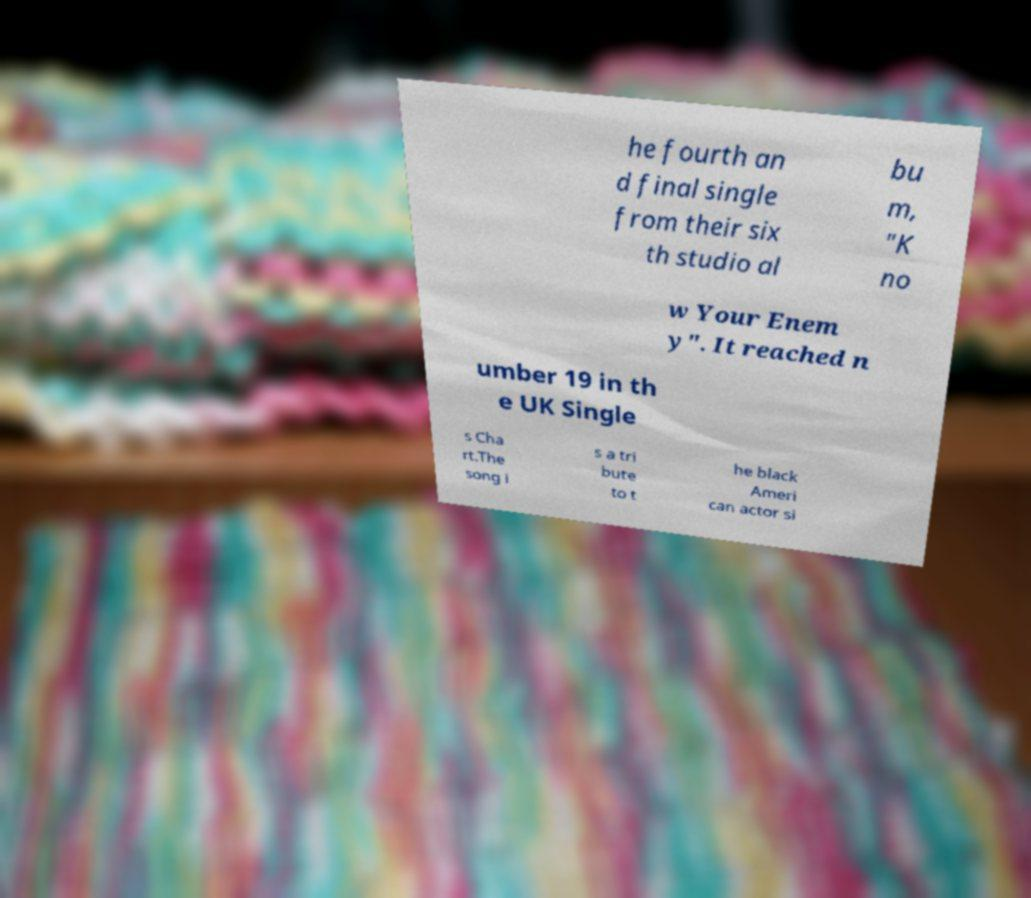Please read and relay the text visible in this image. What does it say? he fourth an d final single from their six th studio al bu m, "K no w Your Enem y". It reached n umber 19 in th e UK Single s Cha rt.The song i s a tri bute to t he black Ameri can actor si 